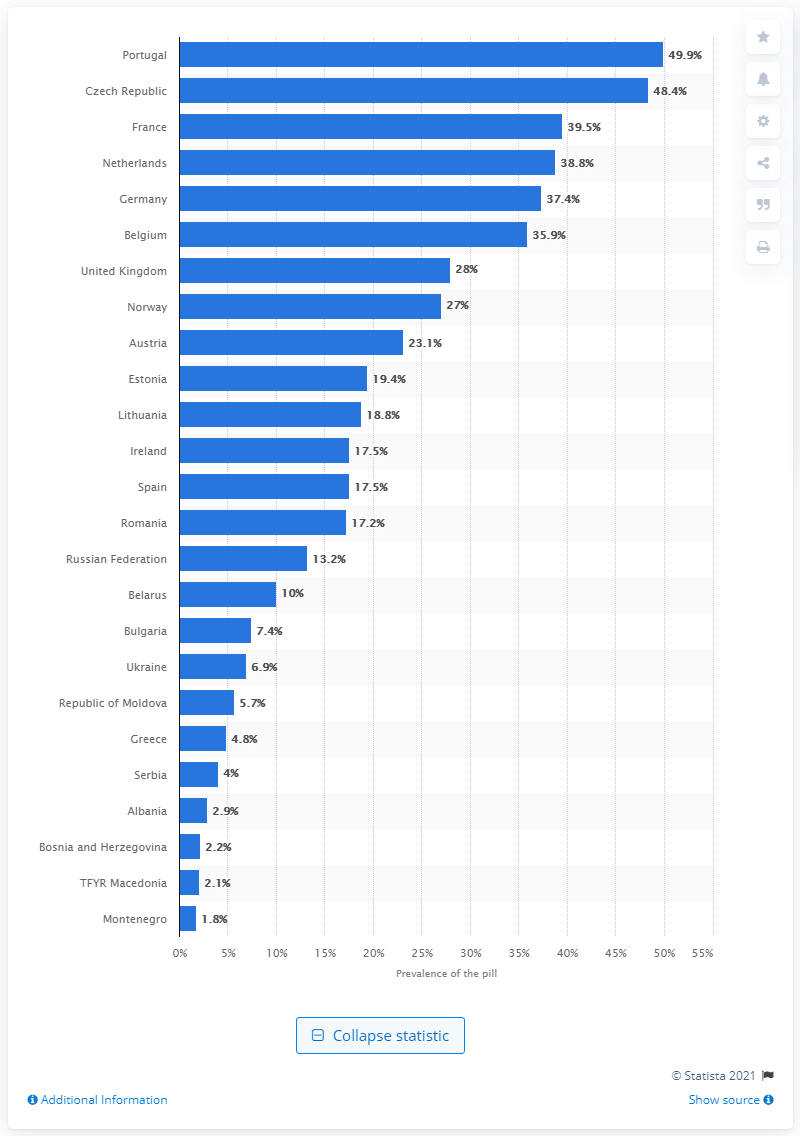Specify some key components in this picture. In 2015, 49.9% of married or in-union women in Portugal used the pill as a method of contraception. 